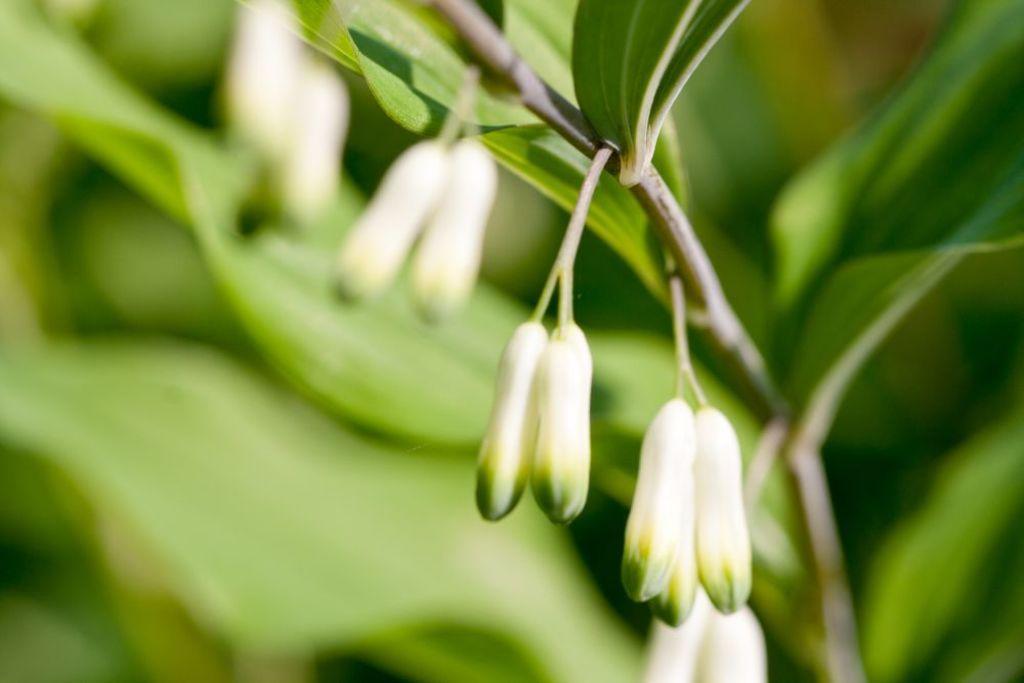Please provide a concise description of this image. In this picture I can observe flower buds. They are in white and green color. The background is blurred. 